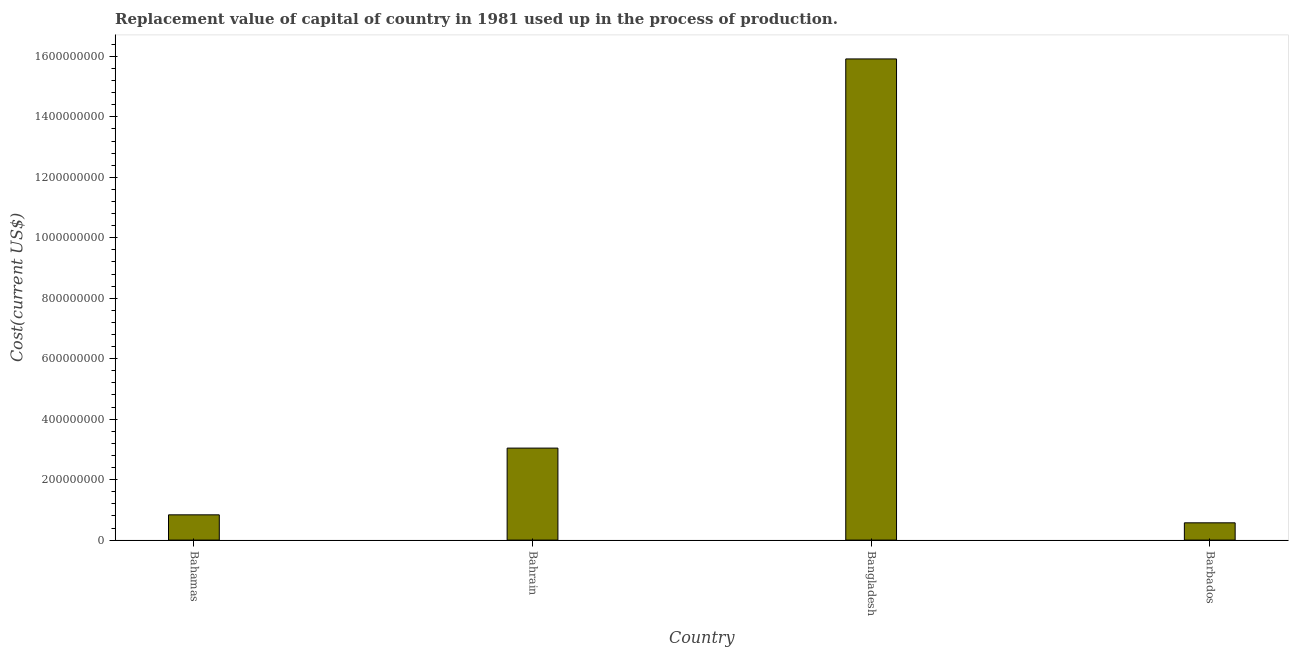Does the graph contain grids?
Provide a succinct answer. No. What is the title of the graph?
Offer a very short reply. Replacement value of capital of country in 1981 used up in the process of production. What is the label or title of the X-axis?
Give a very brief answer. Country. What is the label or title of the Y-axis?
Your answer should be compact. Cost(current US$). What is the consumption of fixed capital in Bahamas?
Provide a succinct answer. 8.36e+07. Across all countries, what is the maximum consumption of fixed capital?
Your answer should be compact. 1.59e+09. Across all countries, what is the minimum consumption of fixed capital?
Your response must be concise. 5.72e+07. In which country was the consumption of fixed capital maximum?
Offer a terse response. Bangladesh. In which country was the consumption of fixed capital minimum?
Provide a succinct answer. Barbados. What is the sum of the consumption of fixed capital?
Provide a succinct answer. 2.04e+09. What is the difference between the consumption of fixed capital in Bahrain and Barbados?
Provide a short and direct response. 2.47e+08. What is the average consumption of fixed capital per country?
Ensure brevity in your answer.  5.09e+08. What is the median consumption of fixed capital?
Your answer should be compact. 1.94e+08. What is the ratio of the consumption of fixed capital in Bahamas to that in Barbados?
Make the answer very short. 1.46. What is the difference between the highest and the second highest consumption of fixed capital?
Your answer should be very brief. 1.29e+09. What is the difference between the highest and the lowest consumption of fixed capital?
Provide a succinct answer. 1.53e+09. In how many countries, is the consumption of fixed capital greater than the average consumption of fixed capital taken over all countries?
Keep it short and to the point. 1. How many bars are there?
Keep it short and to the point. 4. What is the Cost(current US$) in Bahamas?
Your response must be concise. 8.36e+07. What is the Cost(current US$) of Bahrain?
Give a very brief answer. 3.04e+08. What is the Cost(current US$) of Bangladesh?
Your response must be concise. 1.59e+09. What is the Cost(current US$) of Barbados?
Provide a short and direct response. 5.72e+07. What is the difference between the Cost(current US$) in Bahamas and Bahrain?
Give a very brief answer. -2.21e+08. What is the difference between the Cost(current US$) in Bahamas and Bangladesh?
Ensure brevity in your answer.  -1.51e+09. What is the difference between the Cost(current US$) in Bahamas and Barbados?
Your answer should be very brief. 2.64e+07. What is the difference between the Cost(current US$) in Bahrain and Bangladesh?
Offer a terse response. -1.29e+09. What is the difference between the Cost(current US$) in Bahrain and Barbados?
Ensure brevity in your answer.  2.47e+08. What is the difference between the Cost(current US$) in Bangladesh and Barbados?
Your response must be concise. 1.53e+09. What is the ratio of the Cost(current US$) in Bahamas to that in Bahrain?
Your answer should be very brief. 0.28. What is the ratio of the Cost(current US$) in Bahamas to that in Bangladesh?
Make the answer very short. 0.05. What is the ratio of the Cost(current US$) in Bahamas to that in Barbados?
Offer a terse response. 1.46. What is the ratio of the Cost(current US$) in Bahrain to that in Bangladesh?
Provide a short and direct response. 0.19. What is the ratio of the Cost(current US$) in Bahrain to that in Barbados?
Make the answer very short. 5.32. What is the ratio of the Cost(current US$) in Bangladesh to that in Barbados?
Give a very brief answer. 27.83. 